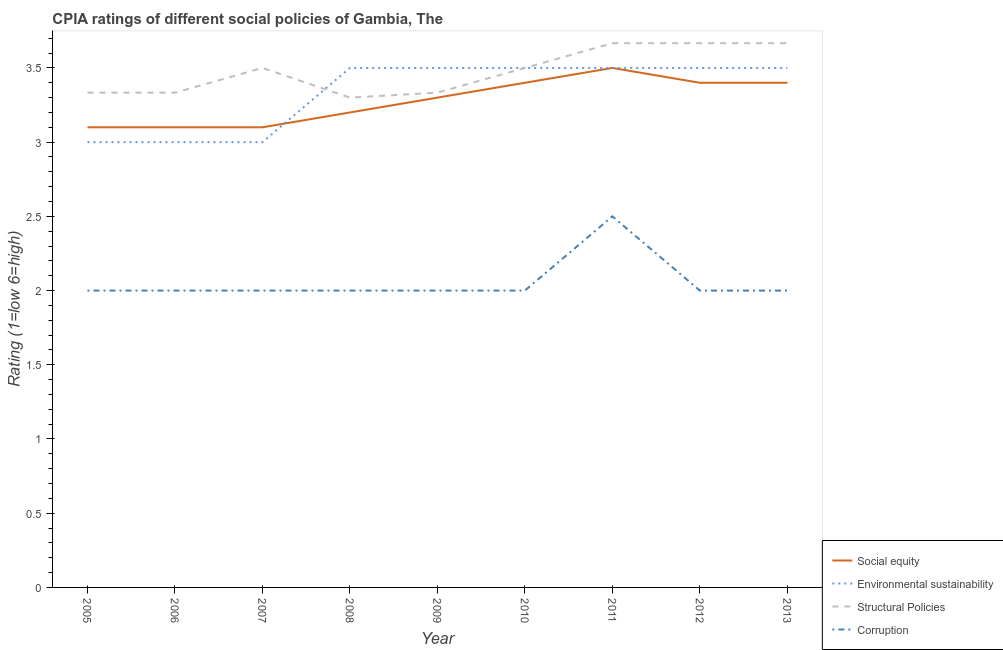Does the line corresponding to cpia rating of corruption intersect with the line corresponding to cpia rating of social equity?
Your response must be concise. No. Across all years, what is the maximum cpia rating of corruption?
Your response must be concise. 2.5. Across all years, what is the minimum cpia rating of social equity?
Your response must be concise. 3.1. In which year was the cpia rating of structural policies maximum?
Offer a very short reply. 2011. In which year was the cpia rating of social equity minimum?
Keep it short and to the point. 2005. What is the difference between the cpia rating of structural policies in 2009 and that in 2010?
Make the answer very short. -0.17. What is the average cpia rating of corruption per year?
Give a very brief answer. 2.06. In the year 2005, what is the difference between the cpia rating of social equity and cpia rating of structural policies?
Offer a very short reply. -0.23. In how many years, is the cpia rating of environmental sustainability greater than 2.9?
Your response must be concise. 9. What is the ratio of the cpia rating of social equity in 2007 to that in 2013?
Provide a succinct answer. 0.91. Is the cpia rating of social equity in 2006 less than that in 2007?
Your answer should be compact. No. Is the difference between the cpia rating of corruption in 2007 and 2009 greater than the difference between the cpia rating of environmental sustainability in 2007 and 2009?
Make the answer very short. Yes. What is the difference between the highest and the second highest cpia rating of environmental sustainability?
Keep it short and to the point. 0. What is the difference between the highest and the lowest cpia rating of structural policies?
Give a very brief answer. 0.37. In how many years, is the cpia rating of structural policies greater than the average cpia rating of structural policies taken over all years?
Provide a succinct answer. 5. Is it the case that in every year, the sum of the cpia rating of social equity and cpia rating of structural policies is greater than the sum of cpia rating of environmental sustainability and cpia rating of corruption?
Make the answer very short. No. Does the cpia rating of structural policies monotonically increase over the years?
Ensure brevity in your answer.  No. How many lines are there?
Keep it short and to the point. 4. Does the graph contain any zero values?
Ensure brevity in your answer.  No. Where does the legend appear in the graph?
Your answer should be compact. Bottom right. How are the legend labels stacked?
Keep it short and to the point. Vertical. What is the title of the graph?
Offer a terse response. CPIA ratings of different social policies of Gambia, The. What is the label or title of the X-axis?
Make the answer very short. Year. What is the label or title of the Y-axis?
Give a very brief answer. Rating (1=low 6=high). What is the Rating (1=low 6=high) in Social equity in 2005?
Offer a terse response. 3.1. What is the Rating (1=low 6=high) of Structural Policies in 2005?
Provide a short and direct response. 3.33. What is the Rating (1=low 6=high) of Corruption in 2005?
Your answer should be compact. 2. What is the Rating (1=low 6=high) in Environmental sustainability in 2006?
Make the answer very short. 3. What is the Rating (1=low 6=high) in Structural Policies in 2006?
Provide a short and direct response. 3.33. What is the Rating (1=low 6=high) of Social equity in 2007?
Your answer should be very brief. 3.1. What is the Rating (1=low 6=high) in Corruption in 2007?
Give a very brief answer. 2. What is the Rating (1=low 6=high) of Social equity in 2008?
Give a very brief answer. 3.2. What is the Rating (1=low 6=high) in Environmental sustainability in 2008?
Provide a short and direct response. 3.5. What is the Rating (1=low 6=high) of Corruption in 2008?
Your answer should be compact. 2. What is the Rating (1=low 6=high) of Social equity in 2009?
Your answer should be compact. 3.3. What is the Rating (1=low 6=high) in Environmental sustainability in 2009?
Keep it short and to the point. 3.5. What is the Rating (1=low 6=high) in Structural Policies in 2009?
Your answer should be very brief. 3.33. What is the Rating (1=low 6=high) of Social equity in 2010?
Your response must be concise. 3.4. What is the Rating (1=low 6=high) of Environmental sustainability in 2010?
Offer a very short reply. 3.5. What is the Rating (1=low 6=high) in Structural Policies in 2010?
Your answer should be compact. 3.5. What is the Rating (1=low 6=high) of Corruption in 2010?
Ensure brevity in your answer.  2. What is the Rating (1=low 6=high) of Social equity in 2011?
Offer a very short reply. 3.5. What is the Rating (1=low 6=high) in Environmental sustainability in 2011?
Make the answer very short. 3.5. What is the Rating (1=low 6=high) of Structural Policies in 2011?
Offer a very short reply. 3.67. What is the Rating (1=low 6=high) of Environmental sustainability in 2012?
Your answer should be compact. 3.5. What is the Rating (1=low 6=high) in Structural Policies in 2012?
Provide a succinct answer. 3.67. What is the Rating (1=low 6=high) of Corruption in 2012?
Your response must be concise. 2. What is the Rating (1=low 6=high) in Social equity in 2013?
Make the answer very short. 3.4. What is the Rating (1=low 6=high) in Environmental sustainability in 2013?
Provide a short and direct response. 3.5. What is the Rating (1=low 6=high) in Structural Policies in 2013?
Your answer should be very brief. 3.67. Across all years, what is the maximum Rating (1=low 6=high) in Social equity?
Your answer should be very brief. 3.5. Across all years, what is the maximum Rating (1=low 6=high) of Structural Policies?
Provide a succinct answer. 3.67. Across all years, what is the maximum Rating (1=low 6=high) of Corruption?
Your response must be concise. 2.5. Across all years, what is the minimum Rating (1=low 6=high) of Environmental sustainability?
Offer a terse response. 3. Across all years, what is the minimum Rating (1=low 6=high) in Structural Policies?
Give a very brief answer. 3.3. Across all years, what is the minimum Rating (1=low 6=high) in Corruption?
Give a very brief answer. 2. What is the total Rating (1=low 6=high) in Social equity in the graph?
Provide a short and direct response. 29.5. What is the total Rating (1=low 6=high) in Environmental sustainability in the graph?
Provide a succinct answer. 30. What is the total Rating (1=low 6=high) in Structural Policies in the graph?
Provide a succinct answer. 31.3. What is the difference between the Rating (1=low 6=high) of Social equity in 2005 and that in 2006?
Ensure brevity in your answer.  0. What is the difference between the Rating (1=low 6=high) in Environmental sustainability in 2005 and that in 2006?
Offer a terse response. 0. What is the difference between the Rating (1=low 6=high) of Environmental sustainability in 2005 and that in 2007?
Offer a terse response. 0. What is the difference between the Rating (1=low 6=high) of Social equity in 2005 and that in 2008?
Make the answer very short. -0.1. What is the difference between the Rating (1=low 6=high) of Environmental sustainability in 2005 and that in 2008?
Provide a short and direct response. -0.5. What is the difference between the Rating (1=low 6=high) of Environmental sustainability in 2005 and that in 2009?
Provide a succinct answer. -0.5. What is the difference between the Rating (1=low 6=high) in Corruption in 2005 and that in 2009?
Provide a succinct answer. 0. What is the difference between the Rating (1=low 6=high) of Social equity in 2005 and that in 2011?
Make the answer very short. -0.4. What is the difference between the Rating (1=low 6=high) in Environmental sustainability in 2005 and that in 2011?
Ensure brevity in your answer.  -0.5. What is the difference between the Rating (1=low 6=high) in Corruption in 2005 and that in 2011?
Give a very brief answer. -0.5. What is the difference between the Rating (1=low 6=high) in Social equity in 2005 and that in 2012?
Your answer should be compact. -0.3. What is the difference between the Rating (1=low 6=high) of Corruption in 2005 and that in 2013?
Your answer should be very brief. 0. What is the difference between the Rating (1=low 6=high) in Social equity in 2006 and that in 2007?
Provide a short and direct response. 0. What is the difference between the Rating (1=low 6=high) of Environmental sustainability in 2006 and that in 2007?
Make the answer very short. 0. What is the difference between the Rating (1=low 6=high) in Corruption in 2006 and that in 2007?
Give a very brief answer. 0. What is the difference between the Rating (1=low 6=high) of Social equity in 2006 and that in 2008?
Keep it short and to the point. -0.1. What is the difference between the Rating (1=low 6=high) of Environmental sustainability in 2006 and that in 2008?
Offer a very short reply. -0.5. What is the difference between the Rating (1=low 6=high) of Corruption in 2006 and that in 2008?
Provide a succinct answer. 0. What is the difference between the Rating (1=low 6=high) of Social equity in 2006 and that in 2009?
Offer a terse response. -0.2. What is the difference between the Rating (1=low 6=high) of Structural Policies in 2006 and that in 2009?
Provide a succinct answer. 0. What is the difference between the Rating (1=low 6=high) in Corruption in 2006 and that in 2009?
Provide a succinct answer. 0. What is the difference between the Rating (1=low 6=high) in Social equity in 2006 and that in 2010?
Your response must be concise. -0.3. What is the difference between the Rating (1=low 6=high) of Structural Policies in 2006 and that in 2010?
Provide a short and direct response. -0.17. What is the difference between the Rating (1=low 6=high) in Social equity in 2006 and that in 2011?
Your answer should be compact. -0.4. What is the difference between the Rating (1=low 6=high) in Environmental sustainability in 2006 and that in 2011?
Ensure brevity in your answer.  -0.5. What is the difference between the Rating (1=low 6=high) of Structural Policies in 2006 and that in 2011?
Give a very brief answer. -0.33. What is the difference between the Rating (1=low 6=high) of Corruption in 2006 and that in 2011?
Your answer should be compact. -0.5. What is the difference between the Rating (1=low 6=high) of Social equity in 2006 and that in 2012?
Provide a succinct answer. -0.3. What is the difference between the Rating (1=low 6=high) of Environmental sustainability in 2006 and that in 2013?
Keep it short and to the point. -0.5. What is the difference between the Rating (1=low 6=high) in Corruption in 2006 and that in 2013?
Ensure brevity in your answer.  0. What is the difference between the Rating (1=low 6=high) in Social equity in 2007 and that in 2008?
Your answer should be compact. -0.1. What is the difference between the Rating (1=low 6=high) of Environmental sustainability in 2007 and that in 2009?
Your answer should be very brief. -0.5. What is the difference between the Rating (1=low 6=high) in Structural Policies in 2007 and that in 2009?
Ensure brevity in your answer.  0.17. What is the difference between the Rating (1=low 6=high) in Corruption in 2007 and that in 2009?
Offer a very short reply. 0. What is the difference between the Rating (1=low 6=high) of Environmental sustainability in 2007 and that in 2011?
Make the answer very short. -0.5. What is the difference between the Rating (1=low 6=high) of Structural Policies in 2007 and that in 2011?
Give a very brief answer. -0.17. What is the difference between the Rating (1=low 6=high) of Social equity in 2007 and that in 2012?
Your answer should be compact. -0.3. What is the difference between the Rating (1=low 6=high) in Environmental sustainability in 2007 and that in 2012?
Provide a succinct answer. -0.5. What is the difference between the Rating (1=low 6=high) of Structural Policies in 2007 and that in 2012?
Your response must be concise. -0.17. What is the difference between the Rating (1=low 6=high) in Corruption in 2007 and that in 2012?
Provide a short and direct response. 0. What is the difference between the Rating (1=low 6=high) in Social equity in 2008 and that in 2009?
Keep it short and to the point. -0.1. What is the difference between the Rating (1=low 6=high) of Environmental sustainability in 2008 and that in 2009?
Give a very brief answer. 0. What is the difference between the Rating (1=low 6=high) in Structural Policies in 2008 and that in 2009?
Provide a succinct answer. -0.03. What is the difference between the Rating (1=low 6=high) in Corruption in 2008 and that in 2009?
Your answer should be compact. 0. What is the difference between the Rating (1=low 6=high) in Social equity in 2008 and that in 2010?
Offer a terse response. -0.2. What is the difference between the Rating (1=low 6=high) of Corruption in 2008 and that in 2010?
Your answer should be compact. 0. What is the difference between the Rating (1=low 6=high) in Environmental sustainability in 2008 and that in 2011?
Give a very brief answer. 0. What is the difference between the Rating (1=low 6=high) in Structural Policies in 2008 and that in 2011?
Make the answer very short. -0.37. What is the difference between the Rating (1=low 6=high) of Corruption in 2008 and that in 2011?
Provide a succinct answer. -0.5. What is the difference between the Rating (1=low 6=high) in Social equity in 2008 and that in 2012?
Offer a terse response. -0.2. What is the difference between the Rating (1=low 6=high) of Environmental sustainability in 2008 and that in 2012?
Offer a very short reply. 0. What is the difference between the Rating (1=low 6=high) in Structural Policies in 2008 and that in 2012?
Your answer should be very brief. -0.37. What is the difference between the Rating (1=low 6=high) in Environmental sustainability in 2008 and that in 2013?
Keep it short and to the point. 0. What is the difference between the Rating (1=low 6=high) of Structural Policies in 2008 and that in 2013?
Offer a very short reply. -0.37. What is the difference between the Rating (1=low 6=high) in Environmental sustainability in 2009 and that in 2010?
Offer a very short reply. 0. What is the difference between the Rating (1=low 6=high) of Structural Policies in 2009 and that in 2010?
Your response must be concise. -0.17. What is the difference between the Rating (1=low 6=high) of Corruption in 2009 and that in 2010?
Offer a very short reply. 0. What is the difference between the Rating (1=low 6=high) of Social equity in 2009 and that in 2011?
Provide a short and direct response. -0.2. What is the difference between the Rating (1=low 6=high) of Environmental sustainability in 2009 and that in 2011?
Your answer should be compact. 0. What is the difference between the Rating (1=low 6=high) in Structural Policies in 2009 and that in 2011?
Make the answer very short. -0.33. What is the difference between the Rating (1=low 6=high) in Social equity in 2009 and that in 2013?
Make the answer very short. -0.1. What is the difference between the Rating (1=low 6=high) in Environmental sustainability in 2009 and that in 2013?
Offer a terse response. 0. What is the difference between the Rating (1=low 6=high) of Social equity in 2010 and that in 2011?
Provide a succinct answer. -0.1. What is the difference between the Rating (1=low 6=high) in Structural Policies in 2010 and that in 2011?
Provide a short and direct response. -0.17. What is the difference between the Rating (1=low 6=high) of Corruption in 2010 and that in 2011?
Ensure brevity in your answer.  -0.5. What is the difference between the Rating (1=low 6=high) of Environmental sustainability in 2010 and that in 2012?
Ensure brevity in your answer.  0. What is the difference between the Rating (1=low 6=high) of Structural Policies in 2010 and that in 2012?
Give a very brief answer. -0.17. What is the difference between the Rating (1=low 6=high) in Environmental sustainability in 2010 and that in 2013?
Your response must be concise. 0. What is the difference between the Rating (1=low 6=high) in Structural Policies in 2011 and that in 2012?
Your response must be concise. 0. What is the difference between the Rating (1=low 6=high) in Social equity in 2011 and that in 2013?
Your response must be concise. 0.1. What is the difference between the Rating (1=low 6=high) in Environmental sustainability in 2011 and that in 2013?
Offer a terse response. 0. What is the difference between the Rating (1=low 6=high) of Structural Policies in 2011 and that in 2013?
Your answer should be very brief. 0. What is the difference between the Rating (1=low 6=high) in Corruption in 2011 and that in 2013?
Keep it short and to the point. 0.5. What is the difference between the Rating (1=low 6=high) in Social equity in 2005 and the Rating (1=low 6=high) in Environmental sustainability in 2006?
Your answer should be very brief. 0.1. What is the difference between the Rating (1=low 6=high) of Social equity in 2005 and the Rating (1=low 6=high) of Structural Policies in 2006?
Your answer should be very brief. -0.23. What is the difference between the Rating (1=low 6=high) of Environmental sustainability in 2005 and the Rating (1=low 6=high) of Structural Policies in 2006?
Your response must be concise. -0.33. What is the difference between the Rating (1=low 6=high) of Social equity in 2005 and the Rating (1=low 6=high) of Environmental sustainability in 2007?
Give a very brief answer. 0.1. What is the difference between the Rating (1=low 6=high) of Environmental sustainability in 2005 and the Rating (1=low 6=high) of Structural Policies in 2007?
Give a very brief answer. -0.5. What is the difference between the Rating (1=low 6=high) of Structural Policies in 2005 and the Rating (1=low 6=high) of Corruption in 2007?
Offer a terse response. 1.33. What is the difference between the Rating (1=low 6=high) of Social equity in 2005 and the Rating (1=low 6=high) of Environmental sustainability in 2008?
Ensure brevity in your answer.  -0.4. What is the difference between the Rating (1=low 6=high) of Social equity in 2005 and the Rating (1=low 6=high) of Structural Policies in 2008?
Your answer should be very brief. -0.2. What is the difference between the Rating (1=low 6=high) of Social equity in 2005 and the Rating (1=low 6=high) of Corruption in 2008?
Your answer should be very brief. 1.1. What is the difference between the Rating (1=low 6=high) of Environmental sustainability in 2005 and the Rating (1=low 6=high) of Structural Policies in 2008?
Your answer should be very brief. -0.3. What is the difference between the Rating (1=low 6=high) in Structural Policies in 2005 and the Rating (1=low 6=high) in Corruption in 2008?
Give a very brief answer. 1.33. What is the difference between the Rating (1=low 6=high) of Social equity in 2005 and the Rating (1=low 6=high) of Structural Policies in 2009?
Your answer should be compact. -0.23. What is the difference between the Rating (1=low 6=high) of Social equity in 2005 and the Rating (1=low 6=high) of Environmental sustainability in 2010?
Your answer should be compact. -0.4. What is the difference between the Rating (1=low 6=high) in Social equity in 2005 and the Rating (1=low 6=high) in Corruption in 2010?
Provide a short and direct response. 1.1. What is the difference between the Rating (1=low 6=high) of Environmental sustainability in 2005 and the Rating (1=low 6=high) of Structural Policies in 2010?
Your answer should be very brief. -0.5. What is the difference between the Rating (1=low 6=high) in Environmental sustainability in 2005 and the Rating (1=low 6=high) in Corruption in 2010?
Make the answer very short. 1. What is the difference between the Rating (1=low 6=high) in Structural Policies in 2005 and the Rating (1=low 6=high) in Corruption in 2010?
Offer a very short reply. 1.33. What is the difference between the Rating (1=low 6=high) of Social equity in 2005 and the Rating (1=low 6=high) of Environmental sustainability in 2011?
Offer a very short reply. -0.4. What is the difference between the Rating (1=low 6=high) in Social equity in 2005 and the Rating (1=low 6=high) in Structural Policies in 2011?
Your answer should be compact. -0.57. What is the difference between the Rating (1=low 6=high) in Environmental sustainability in 2005 and the Rating (1=low 6=high) in Structural Policies in 2011?
Keep it short and to the point. -0.67. What is the difference between the Rating (1=low 6=high) in Environmental sustainability in 2005 and the Rating (1=low 6=high) in Corruption in 2011?
Offer a very short reply. 0.5. What is the difference between the Rating (1=low 6=high) in Social equity in 2005 and the Rating (1=low 6=high) in Structural Policies in 2012?
Provide a succinct answer. -0.57. What is the difference between the Rating (1=low 6=high) in Environmental sustainability in 2005 and the Rating (1=low 6=high) in Structural Policies in 2012?
Provide a succinct answer. -0.67. What is the difference between the Rating (1=low 6=high) of Social equity in 2005 and the Rating (1=low 6=high) of Structural Policies in 2013?
Provide a succinct answer. -0.57. What is the difference between the Rating (1=low 6=high) in Social equity in 2006 and the Rating (1=low 6=high) in Environmental sustainability in 2007?
Your response must be concise. 0.1. What is the difference between the Rating (1=low 6=high) in Social equity in 2006 and the Rating (1=low 6=high) in Structural Policies in 2007?
Ensure brevity in your answer.  -0.4. What is the difference between the Rating (1=low 6=high) of Social equity in 2006 and the Rating (1=low 6=high) of Corruption in 2007?
Your answer should be compact. 1.1. What is the difference between the Rating (1=low 6=high) in Social equity in 2006 and the Rating (1=low 6=high) in Environmental sustainability in 2008?
Keep it short and to the point. -0.4. What is the difference between the Rating (1=low 6=high) in Social equity in 2006 and the Rating (1=low 6=high) in Structural Policies in 2008?
Your answer should be very brief. -0.2. What is the difference between the Rating (1=low 6=high) in Environmental sustainability in 2006 and the Rating (1=low 6=high) in Structural Policies in 2008?
Provide a succinct answer. -0.3. What is the difference between the Rating (1=low 6=high) in Environmental sustainability in 2006 and the Rating (1=low 6=high) in Corruption in 2008?
Provide a short and direct response. 1. What is the difference between the Rating (1=low 6=high) of Structural Policies in 2006 and the Rating (1=low 6=high) of Corruption in 2008?
Offer a very short reply. 1.33. What is the difference between the Rating (1=low 6=high) of Social equity in 2006 and the Rating (1=low 6=high) of Environmental sustainability in 2009?
Provide a short and direct response. -0.4. What is the difference between the Rating (1=low 6=high) in Social equity in 2006 and the Rating (1=low 6=high) in Structural Policies in 2009?
Offer a terse response. -0.23. What is the difference between the Rating (1=low 6=high) in Environmental sustainability in 2006 and the Rating (1=low 6=high) in Corruption in 2009?
Ensure brevity in your answer.  1. What is the difference between the Rating (1=low 6=high) of Structural Policies in 2006 and the Rating (1=low 6=high) of Corruption in 2009?
Give a very brief answer. 1.33. What is the difference between the Rating (1=low 6=high) in Social equity in 2006 and the Rating (1=low 6=high) in Corruption in 2010?
Provide a succinct answer. 1.1. What is the difference between the Rating (1=low 6=high) in Environmental sustainability in 2006 and the Rating (1=low 6=high) in Structural Policies in 2010?
Your response must be concise. -0.5. What is the difference between the Rating (1=low 6=high) of Environmental sustainability in 2006 and the Rating (1=low 6=high) of Corruption in 2010?
Offer a very short reply. 1. What is the difference between the Rating (1=low 6=high) in Structural Policies in 2006 and the Rating (1=low 6=high) in Corruption in 2010?
Offer a very short reply. 1.33. What is the difference between the Rating (1=low 6=high) of Social equity in 2006 and the Rating (1=low 6=high) of Environmental sustainability in 2011?
Ensure brevity in your answer.  -0.4. What is the difference between the Rating (1=low 6=high) in Social equity in 2006 and the Rating (1=low 6=high) in Structural Policies in 2011?
Provide a succinct answer. -0.57. What is the difference between the Rating (1=low 6=high) in Environmental sustainability in 2006 and the Rating (1=low 6=high) in Structural Policies in 2011?
Provide a succinct answer. -0.67. What is the difference between the Rating (1=low 6=high) of Social equity in 2006 and the Rating (1=low 6=high) of Structural Policies in 2012?
Keep it short and to the point. -0.57. What is the difference between the Rating (1=low 6=high) of Social equity in 2006 and the Rating (1=low 6=high) of Corruption in 2012?
Offer a very short reply. 1.1. What is the difference between the Rating (1=low 6=high) of Environmental sustainability in 2006 and the Rating (1=low 6=high) of Structural Policies in 2012?
Keep it short and to the point. -0.67. What is the difference between the Rating (1=low 6=high) in Social equity in 2006 and the Rating (1=low 6=high) in Environmental sustainability in 2013?
Your response must be concise. -0.4. What is the difference between the Rating (1=low 6=high) in Social equity in 2006 and the Rating (1=low 6=high) in Structural Policies in 2013?
Your answer should be very brief. -0.57. What is the difference between the Rating (1=low 6=high) of Social equity in 2006 and the Rating (1=low 6=high) of Corruption in 2013?
Make the answer very short. 1.1. What is the difference between the Rating (1=low 6=high) of Environmental sustainability in 2006 and the Rating (1=low 6=high) of Corruption in 2013?
Offer a terse response. 1. What is the difference between the Rating (1=low 6=high) in Environmental sustainability in 2007 and the Rating (1=low 6=high) in Structural Policies in 2008?
Your response must be concise. -0.3. What is the difference between the Rating (1=low 6=high) in Social equity in 2007 and the Rating (1=low 6=high) in Environmental sustainability in 2009?
Make the answer very short. -0.4. What is the difference between the Rating (1=low 6=high) in Social equity in 2007 and the Rating (1=low 6=high) in Structural Policies in 2009?
Your answer should be very brief. -0.23. What is the difference between the Rating (1=low 6=high) in Social equity in 2007 and the Rating (1=low 6=high) in Corruption in 2009?
Your answer should be compact. 1.1. What is the difference between the Rating (1=low 6=high) in Environmental sustainability in 2007 and the Rating (1=low 6=high) in Structural Policies in 2009?
Your response must be concise. -0.33. What is the difference between the Rating (1=low 6=high) of Social equity in 2007 and the Rating (1=low 6=high) of Environmental sustainability in 2010?
Make the answer very short. -0.4. What is the difference between the Rating (1=low 6=high) in Social equity in 2007 and the Rating (1=low 6=high) in Structural Policies in 2010?
Offer a terse response. -0.4. What is the difference between the Rating (1=low 6=high) of Social equity in 2007 and the Rating (1=low 6=high) of Structural Policies in 2011?
Your answer should be very brief. -0.57. What is the difference between the Rating (1=low 6=high) of Social equity in 2007 and the Rating (1=low 6=high) of Corruption in 2011?
Ensure brevity in your answer.  0.6. What is the difference between the Rating (1=low 6=high) in Environmental sustainability in 2007 and the Rating (1=low 6=high) in Structural Policies in 2011?
Keep it short and to the point. -0.67. What is the difference between the Rating (1=low 6=high) in Environmental sustainability in 2007 and the Rating (1=low 6=high) in Corruption in 2011?
Make the answer very short. 0.5. What is the difference between the Rating (1=low 6=high) in Structural Policies in 2007 and the Rating (1=low 6=high) in Corruption in 2011?
Provide a short and direct response. 1. What is the difference between the Rating (1=low 6=high) of Social equity in 2007 and the Rating (1=low 6=high) of Structural Policies in 2012?
Your answer should be compact. -0.57. What is the difference between the Rating (1=low 6=high) in Environmental sustainability in 2007 and the Rating (1=low 6=high) in Corruption in 2012?
Offer a very short reply. 1. What is the difference between the Rating (1=low 6=high) in Social equity in 2007 and the Rating (1=low 6=high) in Structural Policies in 2013?
Your answer should be compact. -0.57. What is the difference between the Rating (1=low 6=high) in Social equity in 2007 and the Rating (1=low 6=high) in Corruption in 2013?
Your answer should be compact. 1.1. What is the difference between the Rating (1=low 6=high) of Environmental sustainability in 2007 and the Rating (1=low 6=high) of Structural Policies in 2013?
Provide a short and direct response. -0.67. What is the difference between the Rating (1=low 6=high) of Environmental sustainability in 2007 and the Rating (1=low 6=high) of Corruption in 2013?
Make the answer very short. 1. What is the difference between the Rating (1=low 6=high) of Structural Policies in 2007 and the Rating (1=low 6=high) of Corruption in 2013?
Keep it short and to the point. 1.5. What is the difference between the Rating (1=low 6=high) of Social equity in 2008 and the Rating (1=low 6=high) of Structural Policies in 2009?
Make the answer very short. -0.13. What is the difference between the Rating (1=low 6=high) in Social equity in 2008 and the Rating (1=low 6=high) in Corruption in 2009?
Ensure brevity in your answer.  1.2. What is the difference between the Rating (1=low 6=high) of Environmental sustainability in 2008 and the Rating (1=low 6=high) of Corruption in 2009?
Provide a succinct answer. 1.5. What is the difference between the Rating (1=low 6=high) of Structural Policies in 2008 and the Rating (1=low 6=high) of Corruption in 2009?
Make the answer very short. 1.3. What is the difference between the Rating (1=low 6=high) of Social equity in 2008 and the Rating (1=low 6=high) of Environmental sustainability in 2010?
Your answer should be compact. -0.3. What is the difference between the Rating (1=low 6=high) in Social equity in 2008 and the Rating (1=low 6=high) in Structural Policies in 2010?
Offer a very short reply. -0.3. What is the difference between the Rating (1=low 6=high) of Environmental sustainability in 2008 and the Rating (1=low 6=high) of Structural Policies in 2010?
Give a very brief answer. 0. What is the difference between the Rating (1=low 6=high) of Environmental sustainability in 2008 and the Rating (1=low 6=high) of Corruption in 2010?
Provide a short and direct response. 1.5. What is the difference between the Rating (1=low 6=high) of Social equity in 2008 and the Rating (1=low 6=high) of Environmental sustainability in 2011?
Your answer should be compact. -0.3. What is the difference between the Rating (1=low 6=high) of Social equity in 2008 and the Rating (1=low 6=high) of Structural Policies in 2011?
Offer a terse response. -0.47. What is the difference between the Rating (1=low 6=high) in Social equity in 2008 and the Rating (1=low 6=high) in Corruption in 2011?
Your answer should be compact. 0.7. What is the difference between the Rating (1=low 6=high) in Environmental sustainability in 2008 and the Rating (1=low 6=high) in Structural Policies in 2011?
Your response must be concise. -0.17. What is the difference between the Rating (1=low 6=high) of Structural Policies in 2008 and the Rating (1=low 6=high) of Corruption in 2011?
Your answer should be very brief. 0.8. What is the difference between the Rating (1=low 6=high) in Social equity in 2008 and the Rating (1=low 6=high) in Environmental sustainability in 2012?
Your answer should be compact. -0.3. What is the difference between the Rating (1=low 6=high) of Social equity in 2008 and the Rating (1=low 6=high) of Structural Policies in 2012?
Provide a succinct answer. -0.47. What is the difference between the Rating (1=low 6=high) in Social equity in 2008 and the Rating (1=low 6=high) in Environmental sustainability in 2013?
Your answer should be very brief. -0.3. What is the difference between the Rating (1=low 6=high) of Social equity in 2008 and the Rating (1=low 6=high) of Structural Policies in 2013?
Ensure brevity in your answer.  -0.47. What is the difference between the Rating (1=low 6=high) of Environmental sustainability in 2008 and the Rating (1=low 6=high) of Structural Policies in 2013?
Offer a terse response. -0.17. What is the difference between the Rating (1=low 6=high) of Environmental sustainability in 2008 and the Rating (1=low 6=high) of Corruption in 2013?
Your answer should be compact. 1.5. What is the difference between the Rating (1=low 6=high) in Social equity in 2009 and the Rating (1=low 6=high) in Environmental sustainability in 2010?
Keep it short and to the point. -0.2. What is the difference between the Rating (1=low 6=high) in Social equity in 2009 and the Rating (1=low 6=high) in Structural Policies in 2010?
Keep it short and to the point. -0.2. What is the difference between the Rating (1=low 6=high) in Environmental sustainability in 2009 and the Rating (1=low 6=high) in Corruption in 2010?
Ensure brevity in your answer.  1.5. What is the difference between the Rating (1=low 6=high) of Social equity in 2009 and the Rating (1=low 6=high) of Environmental sustainability in 2011?
Your answer should be compact. -0.2. What is the difference between the Rating (1=low 6=high) in Social equity in 2009 and the Rating (1=low 6=high) in Structural Policies in 2011?
Give a very brief answer. -0.37. What is the difference between the Rating (1=low 6=high) in Environmental sustainability in 2009 and the Rating (1=low 6=high) in Structural Policies in 2011?
Provide a short and direct response. -0.17. What is the difference between the Rating (1=low 6=high) of Structural Policies in 2009 and the Rating (1=low 6=high) of Corruption in 2011?
Make the answer very short. 0.83. What is the difference between the Rating (1=low 6=high) in Social equity in 2009 and the Rating (1=low 6=high) in Structural Policies in 2012?
Your response must be concise. -0.37. What is the difference between the Rating (1=low 6=high) in Social equity in 2009 and the Rating (1=low 6=high) in Corruption in 2012?
Keep it short and to the point. 1.3. What is the difference between the Rating (1=low 6=high) of Social equity in 2009 and the Rating (1=low 6=high) of Environmental sustainability in 2013?
Offer a terse response. -0.2. What is the difference between the Rating (1=low 6=high) of Social equity in 2009 and the Rating (1=low 6=high) of Structural Policies in 2013?
Offer a terse response. -0.37. What is the difference between the Rating (1=low 6=high) of Social equity in 2009 and the Rating (1=low 6=high) of Corruption in 2013?
Keep it short and to the point. 1.3. What is the difference between the Rating (1=low 6=high) of Social equity in 2010 and the Rating (1=low 6=high) of Environmental sustainability in 2011?
Offer a very short reply. -0.1. What is the difference between the Rating (1=low 6=high) of Social equity in 2010 and the Rating (1=low 6=high) of Structural Policies in 2011?
Ensure brevity in your answer.  -0.27. What is the difference between the Rating (1=low 6=high) in Social equity in 2010 and the Rating (1=low 6=high) in Corruption in 2011?
Give a very brief answer. 0.9. What is the difference between the Rating (1=low 6=high) in Social equity in 2010 and the Rating (1=low 6=high) in Environmental sustainability in 2012?
Offer a very short reply. -0.1. What is the difference between the Rating (1=low 6=high) of Social equity in 2010 and the Rating (1=low 6=high) of Structural Policies in 2012?
Provide a short and direct response. -0.27. What is the difference between the Rating (1=low 6=high) in Environmental sustainability in 2010 and the Rating (1=low 6=high) in Structural Policies in 2012?
Offer a terse response. -0.17. What is the difference between the Rating (1=low 6=high) in Environmental sustainability in 2010 and the Rating (1=low 6=high) in Corruption in 2012?
Offer a very short reply. 1.5. What is the difference between the Rating (1=low 6=high) of Structural Policies in 2010 and the Rating (1=low 6=high) of Corruption in 2012?
Ensure brevity in your answer.  1.5. What is the difference between the Rating (1=low 6=high) in Social equity in 2010 and the Rating (1=low 6=high) in Environmental sustainability in 2013?
Give a very brief answer. -0.1. What is the difference between the Rating (1=low 6=high) in Social equity in 2010 and the Rating (1=low 6=high) in Structural Policies in 2013?
Ensure brevity in your answer.  -0.27. What is the difference between the Rating (1=low 6=high) in Environmental sustainability in 2010 and the Rating (1=low 6=high) in Structural Policies in 2013?
Offer a very short reply. -0.17. What is the difference between the Rating (1=low 6=high) in Environmental sustainability in 2010 and the Rating (1=low 6=high) in Corruption in 2013?
Offer a very short reply. 1.5. What is the difference between the Rating (1=low 6=high) in Social equity in 2011 and the Rating (1=low 6=high) in Structural Policies in 2012?
Your response must be concise. -0.17. What is the difference between the Rating (1=low 6=high) of Social equity in 2011 and the Rating (1=low 6=high) of Corruption in 2012?
Your answer should be very brief. 1.5. What is the difference between the Rating (1=low 6=high) of Social equity in 2011 and the Rating (1=low 6=high) of Environmental sustainability in 2013?
Keep it short and to the point. 0. What is the difference between the Rating (1=low 6=high) of Social equity in 2011 and the Rating (1=low 6=high) of Corruption in 2013?
Your answer should be compact. 1.5. What is the difference between the Rating (1=low 6=high) in Environmental sustainability in 2011 and the Rating (1=low 6=high) in Structural Policies in 2013?
Give a very brief answer. -0.17. What is the difference between the Rating (1=low 6=high) in Environmental sustainability in 2011 and the Rating (1=low 6=high) in Corruption in 2013?
Give a very brief answer. 1.5. What is the difference between the Rating (1=low 6=high) in Social equity in 2012 and the Rating (1=low 6=high) in Structural Policies in 2013?
Your answer should be compact. -0.27. What is the difference between the Rating (1=low 6=high) in Social equity in 2012 and the Rating (1=low 6=high) in Corruption in 2013?
Your response must be concise. 1.4. What is the difference between the Rating (1=low 6=high) of Environmental sustainability in 2012 and the Rating (1=low 6=high) of Structural Policies in 2013?
Provide a short and direct response. -0.17. What is the difference between the Rating (1=low 6=high) of Structural Policies in 2012 and the Rating (1=low 6=high) of Corruption in 2013?
Offer a very short reply. 1.67. What is the average Rating (1=low 6=high) of Social equity per year?
Your answer should be very brief. 3.28. What is the average Rating (1=low 6=high) in Structural Policies per year?
Offer a terse response. 3.48. What is the average Rating (1=low 6=high) of Corruption per year?
Provide a short and direct response. 2.06. In the year 2005, what is the difference between the Rating (1=low 6=high) in Social equity and Rating (1=low 6=high) in Structural Policies?
Offer a very short reply. -0.23. In the year 2005, what is the difference between the Rating (1=low 6=high) of Social equity and Rating (1=low 6=high) of Corruption?
Make the answer very short. 1.1. In the year 2005, what is the difference between the Rating (1=low 6=high) in Environmental sustainability and Rating (1=low 6=high) in Structural Policies?
Offer a terse response. -0.33. In the year 2006, what is the difference between the Rating (1=low 6=high) in Social equity and Rating (1=low 6=high) in Environmental sustainability?
Keep it short and to the point. 0.1. In the year 2006, what is the difference between the Rating (1=low 6=high) of Social equity and Rating (1=low 6=high) of Structural Policies?
Your answer should be very brief. -0.23. In the year 2006, what is the difference between the Rating (1=low 6=high) of Environmental sustainability and Rating (1=low 6=high) of Structural Policies?
Offer a very short reply. -0.33. In the year 2006, what is the difference between the Rating (1=low 6=high) in Structural Policies and Rating (1=low 6=high) in Corruption?
Keep it short and to the point. 1.33. In the year 2007, what is the difference between the Rating (1=low 6=high) in Social equity and Rating (1=low 6=high) in Environmental sustainability?
Make the answer very short. 0.1. In the year 2007, what is the difference between the Rating (1=low 6=high) in Social equity and Rating (1=low 6=high) in Structural Policies?
Provide a short and direct response. -0.4. In the year 2007, what is the difference between the Rating (1=low 6=high) in Environmental sustainability and Rating (1=low 6=high) in Corruption?
Your answer should be very brief. 1. In the year 2008, what is the difference between the Rating (1=low 6=high) of Social equity and Rating (1=low 6=high) of Structural Policies?
Offer a terse response. -0.1. In the year 2008, what is the difference between the Rating (1=low 6=high) in Social equity and Rating (1=low 6=high) in Corruption?
Your response must be concise. 1.2. In the year 2008, what is the difference between the Rating (1=low 6=high) of Environmental sustainability and Rating (1=low 6=high) of Structural Policies?
Offer a terse response. 0.2. In the year 2008, what is the difference between the Rating (1=low 6=high) of Environmental sustainability and Rating (1=low 6=high) of Corruption?
Ensure brevity in your answer.  1.5. In the year 2009, what is the difference between the Rating (1=low 6=high) in Social equity and Rating (1=low 6=high) in Structural Policies?
Provide a short and direct response. -0.03. In the year 2009, what is the difference between the Rating (1=low 6=high) in Social equity and Rating (1=low 6=high) in Corruption?
Provide a succinct answer. 1.3. In the year 2009, what is the difference between the Rating (1=low 6=high) in Environmental sustainability and Rating (1=low 6=high) in Corruption?
Keep it short and to the point. 1.5. In the year 2009, what is the difference between the Rating (1=low 6=high) in Structural Policies and Rating (1=low 6=high) in Corruption?
Offer a terse response. 1.33. In the year 2010, what is the difference between the Rating (1=low 6=high) of Social equity and Rating (1=low 6=high) of Environmental sustainability?
Provide a succinct answer. -0.1. In the year 2010, what is the difference between the Rating (1=low 6=high) in Social equity and Rating (1=low 6=high) in Structural Policies?
Offer a terse response. -0.1. In the year 2010, what is the difference between the Rating (1=low 6=high) of Social equity and Rating (1=low 6=high) of Corruption?
Your answer should be compact. 1.4. In the year 2010, what is the difference between the Rating (1=low 6=high) of Environmental sustainability and Rating (1=low 6=high) of Corruption?
Make the answer very short. 1.5. In the year 2011, what is the difference between the Rating (1=low 6=high) in Social equity and Rating (1=low 6=high) in Environmental sustainability?
Your answer should be compact. 0. In the year 2011, what is the difference between the Rating (1=low 6=high) in Social equity and Rating (1=low 6=high) in Structural Policies?
Provide a succinct answer. -0.17. In the year 2011, what is the difference between the Rating (1=low 6=high) of Social equity and Rating (1=low 6=high) of Corruption?
Make the answer very short. 1. In the year 2012, what is the difference between the Rating (1=low 6=high) of Social equity and Rating (1=low 6=high) of Environmental sustainability?
Give a very brief answer. -0.1. In the year 2012, what is the difference between the Rating (1=low 6=high) in Social equity and Rating (1=low 6=high) in Structural Policies?
Keep it short and to the point. -0.27. In the year 2012, what is the difference between the Rating (1=low 6=high) in Social equity and Rating (1=low 6=high) in Corruption?
Offer a terse response. 1.4. In the year 2012, what is the difference between the Rating (1=low 6=high) of Environmental sustainability and Rating (1=low 6=high) of Structural Policies?
Your response must be concise. -0.17. In the year 2013, what is the difference between the Rating (1=low 6=high) in Social equity and Rating (1=low 6=high) in Structural Policies?
Provide a succinct answer. -0.27. In the year 2013, what is the difference between the Rating (1=low 6=high) of Social equity and Rating (1=low 6=high) of Corruption?
Offer a terse response. 1.4. What is the ratio of the Rating (1=low 6=high) in Social equity in 2005 to that in 2006?
Your answer should be very brief. 1. What is the ratio of the Rating (1=low 6=high) of Environmental sustainability in 2005 to that in 2006?
Your answer should be compact. 1. What is the ratio of the Rating (1=low 6=high) in Social equity in 2005 to that in 2007?
Offer a terse response. 1. What is the ratio of the Rating (1=low 6=high) in Environmental sustainability in 2005 to that in 2007?
Provide a short and direct response. 1. What is the ratio of the Rating (1=low 6=high) in Structural Policies in 2005 to that in 2007?
Provide a short and direct response. 0.95. What is the ratio of the Rating (1=low 6=high) in Social equity in 2005 to that in 2008?
Provide a short and direct response. 0.97. What is the ratio of the Rating (1=low 6=high) in Environmental sustainability in 2005 to that in 2008?
Offer a very short reply. 0.86. What is the ratio of the Rating (1=low 6=high) in Structural Policies in 2005 to that in 2008?
Your answer should be compact. 1.01. What is the ratio of the Rating (1=low 6=high) in Corruption in 2005 to that in 2008?
Keep it short and to the point. 1. What is the ratio of the Rating (1=low 6=high) in Social equity in 2005 to that in 2009?
Offer a very short reply. 0.94. What is the ratio of the Rating (1=low 6=high) of Structural Policies in 2005 to that in 2009?
Keep it short and to the point. 1. What is the ratio of the Rating (1=low 6=high) in Social equity in 2005 to that in 2010?
Make the answer very short. 0.91. What is the ratio of the Rating (1=low 6=high) in Environmental sustainability in 2005 to that in 2010?
Make the answer very short. 0.86. What is the ratio of the Rating (1=low 6=high) of Social equity in 2005 to that in 2011?
Give a very brief answer. 0.89. What is the ratio of the Rating (1=low 6=high) in Structural Policies in 2005 to that in 2011?
Give a very brief answer. 0.91. What is the ratio of the Rating (1=low 6=high) of Social equity in 2005 to that in 2012?
Your answer should be very brief. 0.91. What is the ratio of the Rating (1=low 6=high) of Social equity in 2005 to that in 2013?
Give a very brief answer. 0.91. What is the ratio of the Rating (1=low 6=high) of Environmental sustainability in 2005 to that in 2013?
Provide a short and direct response. 0.86. What is the ratio of the Rating (1=low 6=high) of Corruption in 2005 to that in 2013?
Give a very brief answer. 1. What is the ratio of the Rating (1=low 6=high) of Corruption in 2006 to that in 2007?
Ensure brevity in your answer.  1. What is the ratio of the Rating (1=low 6=high) of Social equity in 2006 to that in 2008?
Your answer should be compact. 0.97. What is the ratio of the Rating (1=low 6=high) of Environmental sustainability in 2006 to that in 2008?
Provide a short and direct response. 0.86. What is the ratio of the Rating (1=low 6=high) of Corruption in 2006 to that in 2008?
Offer a very short reply. 1. What is the ratio of the Rating (1=low 6=high) in Social equity in 2006 to that in 2009?
Offer a very short reply. 0.94. What is the ratio of the Rating (1=low 6=high) in Environmental sustainability in 2006 to that in 2009?
Make the answer very short. 0.86. What is the ratio of the Rating (1=low 6=high) in Structural Policies in 2006 to that in 2009?
Your answer should be very brief. 1. What is the ratio of the Rating (1=low 6=high) in Corruption in 2006 to that in 2009?
Provide a succinct answer. 1. What is the ratio of the Rating (1=low 6=high) in Social equity in 2006 to that in 2010?
Your answer should be very brief. 0.91. What is the ratio of the Rating (1=low 6=high) in Environmental sustainability in 2006 to that in 2010?
Your response must be concise. 0.86. What is the ratio of the Rating (1=low 6=high) in Structural Policies in 2006 to that in 2010?
Your answer should be very brief. 0.95. What is the ratio of the Rating (1=low 6=high) of Corruption in 2006 to that in 2010?
Offer a terse response. 1. What is the ratio of the Rating (1=low 6=high) of Social equity in 2006 to that in 2011?
Your response must be concise. 0.89. What is the ratio of the Rating (1=low 6=high) of Social equity in 2006 to that in 2012?
Keep it short and to the point. 0.91. What is the ratio of the Rating (1=low 6=high) of Environmental sustainability in 2006 to that in 2012?
Your response must be concise. 0.86. What is the ratio of the Rating (1=low 6=high) of Structural Policies in 2006 to that in 2012?
Provide a succinct answer. 0.91. What is the ratio of the Rating (1=low 6=high) in Social equity in 2006 to that in 2013?
Keep it short and to the point. 0.91. What is the ratio of the Rating (1=low 6=high) of Corruption in 2006 to that in 2013?
Give a very brief answer. 1. What is the ratio of the Rating (1=low 6=high) in Social equity in 2007 to that in 2008?
Your response must be concise. 0.97. What is the ratio of the Rating (1=low 6=high) in Environmental sustainability in 2007 to that in 2008?
Provide a short and direct response. 0.86. What is the ratio of the Rating (1=low 6=high) of Structural Policies in 2007 to that in 2008?
Provide a short and direct response. 1.06. What is the ratio of the Rating (1=low 6=high) of Corruption in 2007 to that in 2008?
Make the answer very short. 1. What is the ratio of the Rating (1=low 6=high) in Social equity in 2007 to that in 2009?
Provide a succinct answer. 0.94. What is the ratio of the Rating (1=low 6=high) in Structural Policies in 2007 to that in 2009?
Your answer should be very brief. 1.05. What is the ratio of the Rating (1=low 6=high) of Corruption in 2007 to that in 2009?
Provide a succinct answer. 1. What is the ratio of the Rating (1=low 6=high) of Social equity in 2007 to that in 2010?
Give a very brief answer. 0.91. What is the ratio of the Rating (1=low 6=high) in Structural Policies in 2007 to that in 2010?
Give a very brief answer. 1. What is the ratio of the Rating (1=low 6=high) of Corruption in 2007 to that in 2010?
Offer a very short reply. 1. What is the ratio of the Rating (1=low 6=high) in Social equity in 2007 to that in 2011?
Your response must be concise. 0.89. What is the ratio of the Rating (1=low 6=high) in Structural Policies in 2007 to that in 2011?
Provide a succinct answer. 0.95. What is the ratio of the Rating (1=low 6=high) of Corruption in 2007 to that in 2011?
Your answer should be very brief. 0.8. What is the ratio of the Rating (1=low 6=high) of Social equity in 2007 to that in 2012?
Offer a very short reply. 0.91. What is the ratio of the Rating (1=low 6=high) in Structural Policies in 2007 to that in 2012?
Your answer should be very brief. 0.95. What is the ratio of the Rating (1=low 6=high) in Social equity in 2007 to that in 2013?
Your response must be concise. 0.91. What is the ratio of the Rating (1=low 6=high) in Structural Policies in 2007 to that in 2013?
Offer a terse response. 0.95. What is the ratio of the Rating (1=low 6=high) in Corruption in 2007 to that in 2013?
Make the answer very short. 1. What is the ratio of the Rating (1=low 6=high) of Social equity in 2008 to that in 2009?
Give a very brief answer. 0.97. What is the ratio of the Rating (1=low 6=high) of Environmental sustainability in 2008 to that in 2009?
Offer a terse response. 1. What is the ratio of the Rating (1=low 6=high) in Corruption in 2008 to that in 2009?
Provide a short and direct response. 1. What is the ratio of the Rating (1=low 6=high) of Structural Policies in 2008 to that in 2010?
Keep it short and to the point. 0.94. What is the ratio of the Rating (1=low 6=high) of Social equity in 2008 to that in 2011?
Offer a terse response. 0.91. What is the ratio of the Rating (1=low 6=high) in Environmental sustainability in 2008 to that in 2011?
Provide a short and direct response. 1. What is the ratio of the Rating (1=low 6=high) of Social equity in 2008 to that in 2012?
Offer a terse response. 0.94. What is the ratio of the Rating (1=low 6=high) of Environmental sustainability in 2008 to that in 2012?
Your response must be concise. 1. What is the ratio of the Rating (1=low 6=high) in Social equity in 2008 to that in 2013?
Offer a very short reply. 0.94. What is the ratio of the Rating (1=low 6=high) of Structural Policies in 2008 to that in 2013?
Offer a terse response. 0.9. What is the ratio of the Rating (1=low 6=high) of Social equity in 2009 to that in 2010?
Ensure brevity in your answer.  0.97. What is the ratio of the Rating (1=low 6=high) in Structural Policies in 2009 to that in 2010?
Offer a very short reply. 0.95. What is the ratio of the Rating (1=low 6=high) of Corruption in 2009 to that in 2010?
Give a very brief answer. 1. What is the ratio of the Rating (1=low 6=high) in Social equity in 2009 to that in 2011?
Keep it short and to the point. 0.94. What is the ratio of the Rating (1=low 6=high) in Environmental sustainability in 2009 to that in 2011?
Your answer should be compact. 1. What is the ratio of the Rating (1=low 6=high) of Social equity in 2009 to that in 2012?
Provide a succinct answer. 0.97. What is the ratio of the Rating (1=low 6=high) of Structural Policies in 2009 to that in 2012?
Keep it short and to the point. 0.91. What is the ratio of the Rating (1=low 6=high) in Social equity in 2009 to that in 2013?
Provide a succinct answer. 0.97. What is the ratio of the Rating (1=low 6=high) of Environmental sustainability in 2009 to that in 2013?
Provide a short and direct response. 1. What is the ratio of the Rating (1=low 6=high) of Structural Policies in 2009 to that in 2013?
Give a very brief answer. 0.91. What is the ratio of the Rating (1=low 6=high) in Corruption in 2009 to that in 2013?
Your response must be concise. 1. What is the ratio of the Rating (1=low 6=high) in Social equity in 2010 to that in 2011?
Your answer should be compact. 0.97. What is the ratio of the Rating (1=low 6=high) of Structural Policies in 2010 to that in 2011?
Ensure brevity in your answer.  0.95. What is the ratio of the Rating (1=low 6=high) in Social equity in 2010 to that in 2012?
Offer a terse response. 1. What is the ratio of the Rating (1=low 6=high) of Environmental sustainability in 2010 to that in 2012?
Keep it short and to the point. 1. What is the ratio of the Rating (1=low 6=high) of Structural Policies in 2010 to that in 2012?
Your answer should be very brief. 0.95. What is the ratio of the Rating (1=low 6=high) of Environmental sustainability in 2010 to that in 2013?
Provide a short and direct response. 1. What is the ratio of the Rating (1=low 6=high) of Structural Policies in 2010 to that in 2013?
Make the answer very short. 0.95. What is the ratio of the Rating (1=low 6=high) in Social equity in 2011 to that in 2012?
Your answer should be very brief. 1.03. What is the ratio of the Rating (1=low 6=high) of Corruption in 2011 to that in 2012?
Make the answer very short. 1.25. What is the ratio of the Rating (1=low 6=high) of Social equity in 2011 to that in 2013?
Your response must be concise. 1.03. What is the ratio of the Rating (1=low 6=high) in Environmental sustainability in 2011 to that in 2013?
Ensure brevity in your answer.  1. What is the ratio of the Rating (1=low 6=high) in Environmental sustainability in 2012 to that in 2013?
Keep it short and to the point. 1. What is the ratio of the Rating (1=low 6=high) in Structural Policies in 2012 to that in 2013?
Give a very brief answer. 1. What is the ratio of the Rating (1=low 6=high) of Corruption in 2012 to that in 2013?
Your answer should be compact. 1. What is the difference between the highest and the second highest Rating (1=low 6=high) of Social equity?
Your answer should be compact. 0.1. What is the difference between the highest and the second highest Rating (1=low 6=high) of Environmental sustainability?
Ensure brevity in your answer.  0. What is the difference between the highest and the second highest Rating (1=low 6=high) in Structural Policies?
Your response must be concise. 0. What is the difference between the highest and the lowest Rating (1=low 6=high) of Environmental sustainability?
Keep it short and to the point. 0.5. What is the difference between the highest and the lowest Rating (1=low 6=high) of Structural Policies?
Provide a short and direct response. 0.37. 